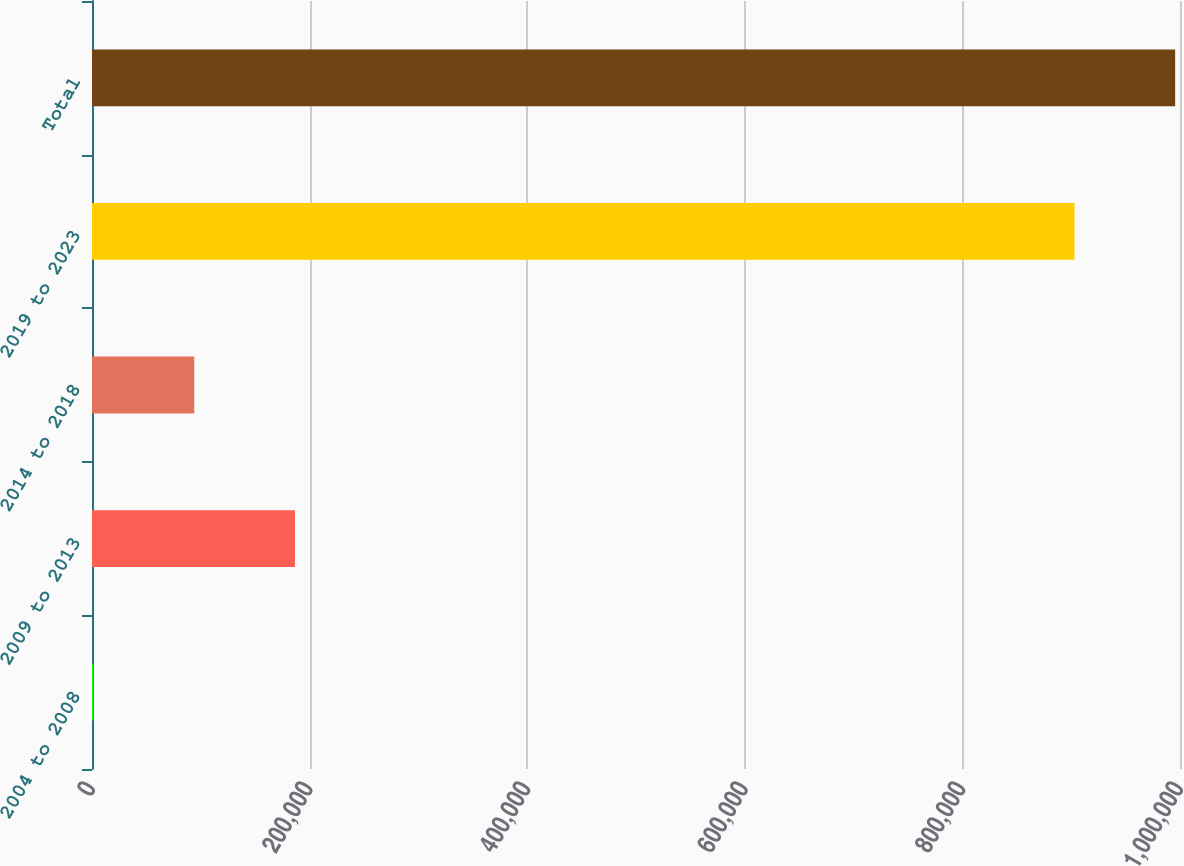Convert chart to OTSL. <chart><loc_0><loc_0><loc_500><loc_500><bar_chart><fcel>2004 to 2008<fcel>2009 to 2013<fcel>2014 to 2018<fcel>2019 to 2023<fcel>Total<nl><fcel>1451<fcel>186538<fcel>93994.5<fcel>903010<fcel>995554<nl></chart> 